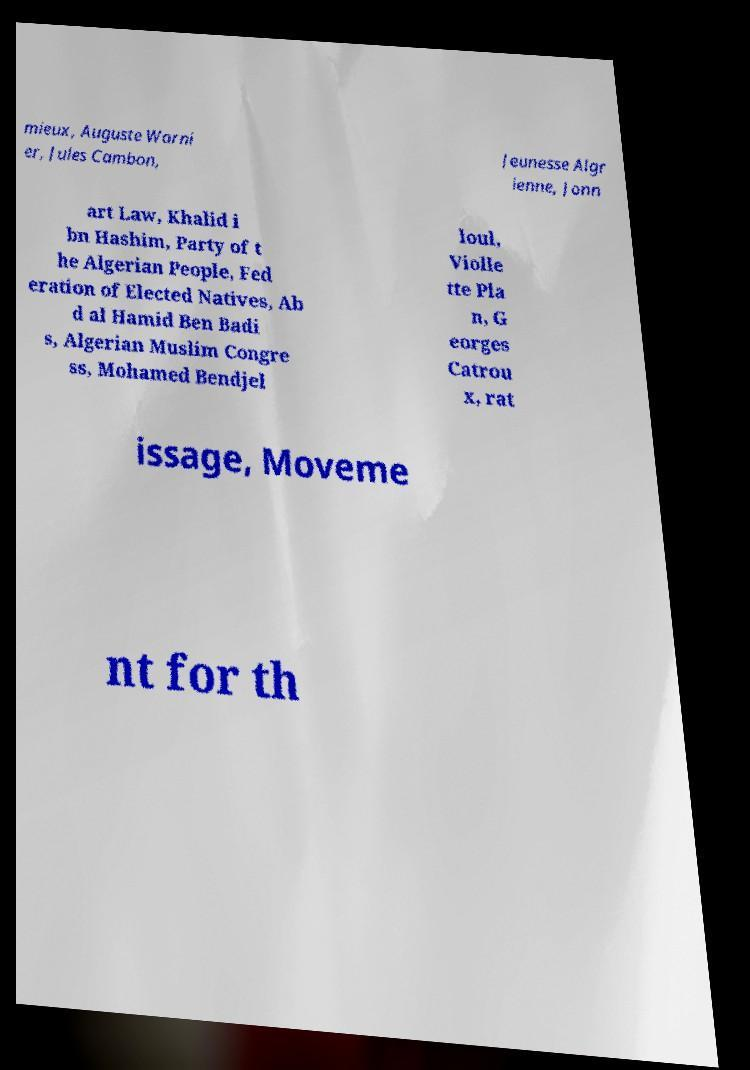What messages or text are displayed in this image? I need them in a readable, typed format. mieux, Auguste Warni er, Jules Cambon, Jeunesse Algr ienne, Jonn art Law, Khalid i bn Hashim, Party of t he Algerian People, Fed eration of Elected Natives, Ab d al Hamid Ben Badi s, Algerian Muslim Congre ss, Mohamed Bendjel loul, Violle tte Pla n, G eorges Catrou x, rat issage, Moveme nt for th 